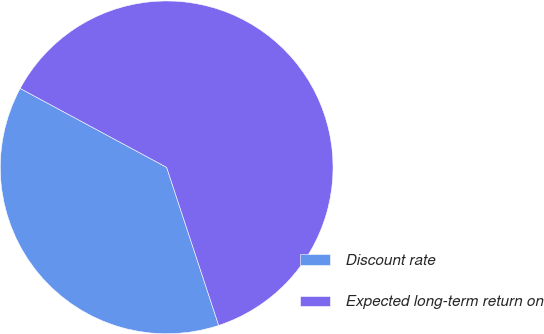Convert chart to OTSL. <chart><loc_0><loc_0><loc_500><loc_500><pie_chart><fcel>Discount rate<fcel>Expected long-term return on<nl><fcel>37.93%<fcel>62.07%<nl></chart> 